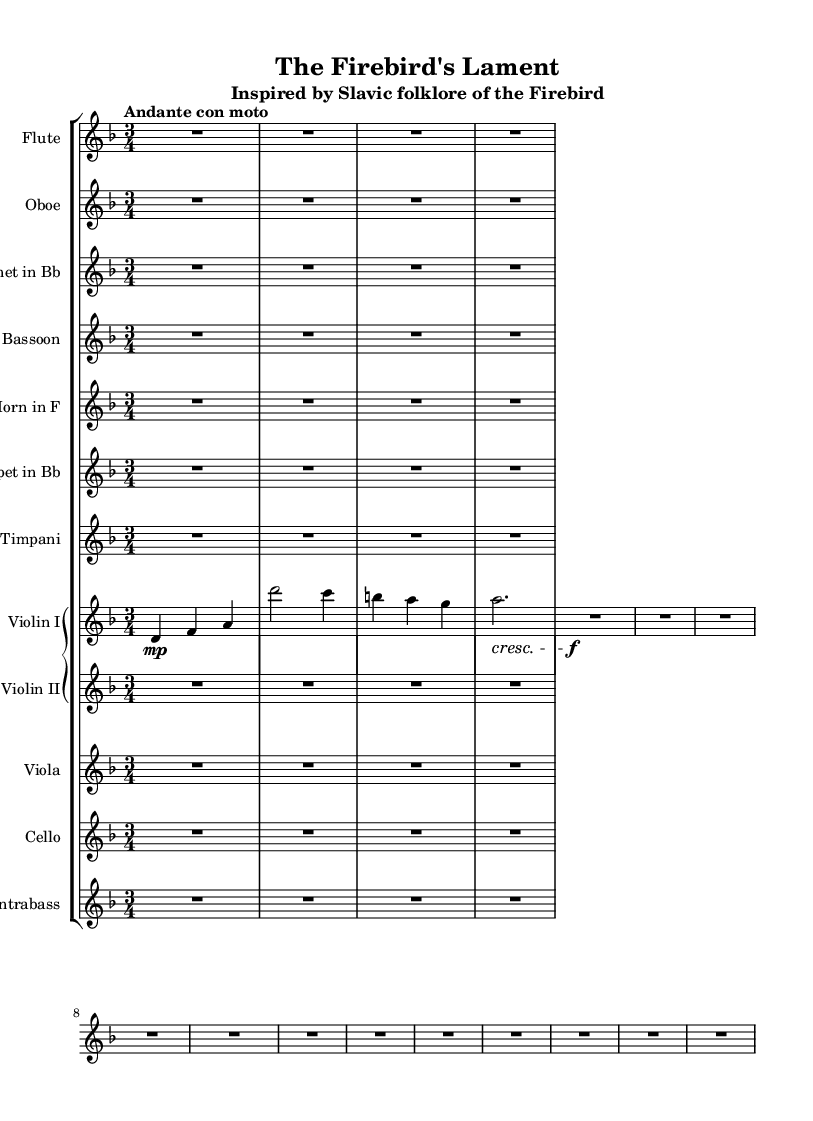What is the title of this symphonic piece? The title is located at the top of the sheet music under the 'header' section. It states "The Firebird's Lament".
Answer: The Firebird's Lament What is the time signature of this music? The time signature can be identified in the global music settings, where it is noted as "3/4", meaning there are three beats per measure.
Answer: 3/4 What is the key signature of this music? The key signature is found in the global section, stated as "d minor", indicating that the piece is written in the key of D minor.
Answer: d minor What tempo marking does this piece have? The tempo marking is provided in the global settings, indicated as "Andante con moto", which refers to a moderately slow tempo with a bit of motion.
Answer: Andante con moto Which instruments are represented in this symphony? Instruments can be deduced from the "StaffGroup" section where various instruments are mentioned like Flute, Oboe, and Violin I, among others. A thorough count shows a total of 10 different instruments listed.
Answer: 10 Which instrument's music starts with a dynamic marking? The Violin I part is the only one that has a dynamic marking at the start, indicated by the symbol "\mp", meaning "mezzo piano" or moderately soft.
Answer: Violin I Describe the form of the symphonic interpretation. The form is indicated by how the music is structured in different staves for each instrument, particularly highlighting themes or motifs derived from Eastern European folklore, such as in the way Violin I presents melodic lines while other instruments support backgrounds.
Answer: Multi-stave orchestration 